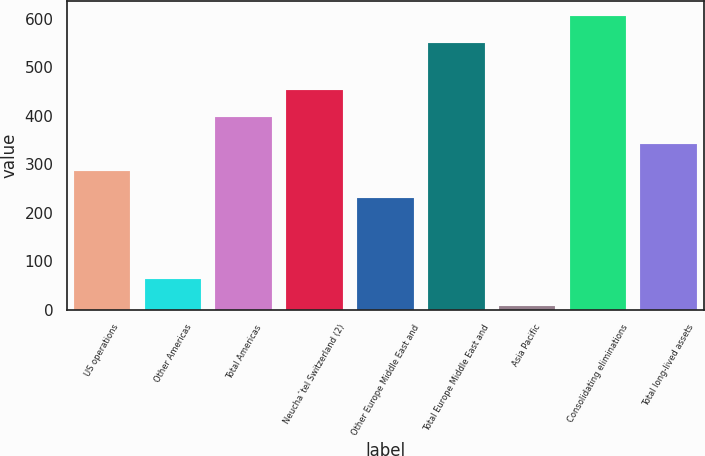Convert chart to OTSL. <chart><loc_0><loc_0><loc_500><loc_500><bar_chart><fcel>US operations<fcel>Other Americas<fcel>Total Americas<fcel>Neuchaˆtel Switzerland (2)<fcel>Other Europe Middle East and<fcel>Total Europe Middle East and<fcel>Asia Pacific<fcel>Consolidating eliminations<fcel>Total long-lived assets<nl><fcel>285.96<fcel>63.56<fcel>396.68<fcel>452.04<fcel>230.6<fcel>549.7<fcel>8.2<fcel>605.06<fcel>341.32<nl></chart> 